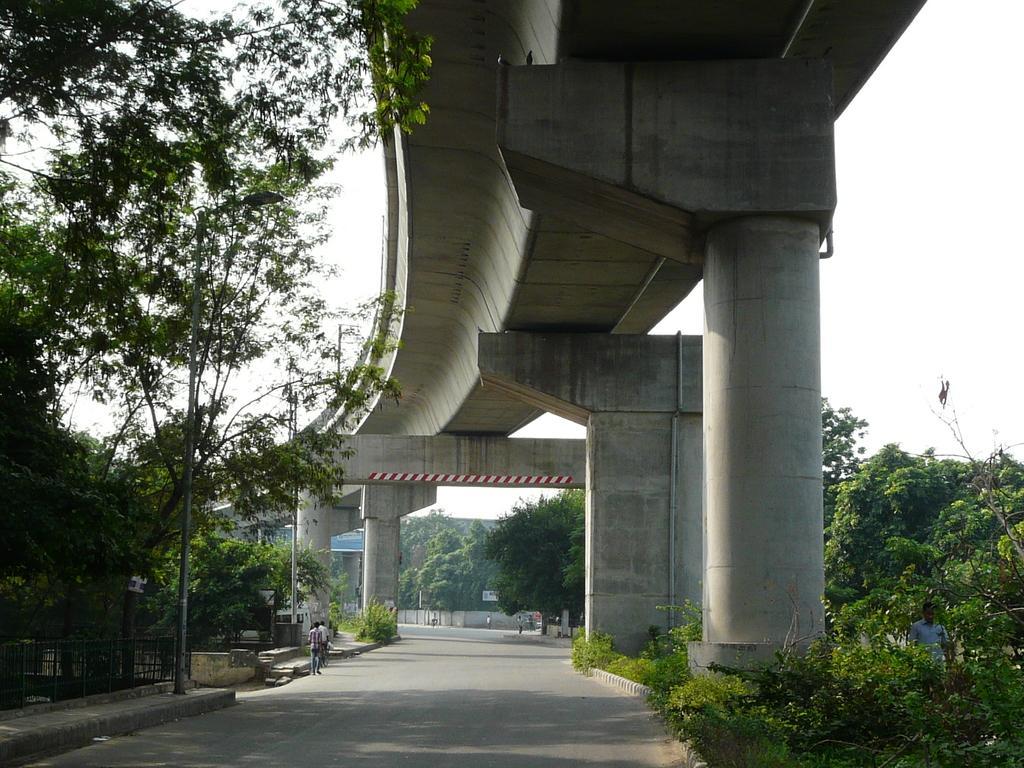Describe this image in one or two sentences. In this image we can see a flyover, there are some pillars, trees, poles, fence, people, boards with some text and the wall, also we can see the sky. 